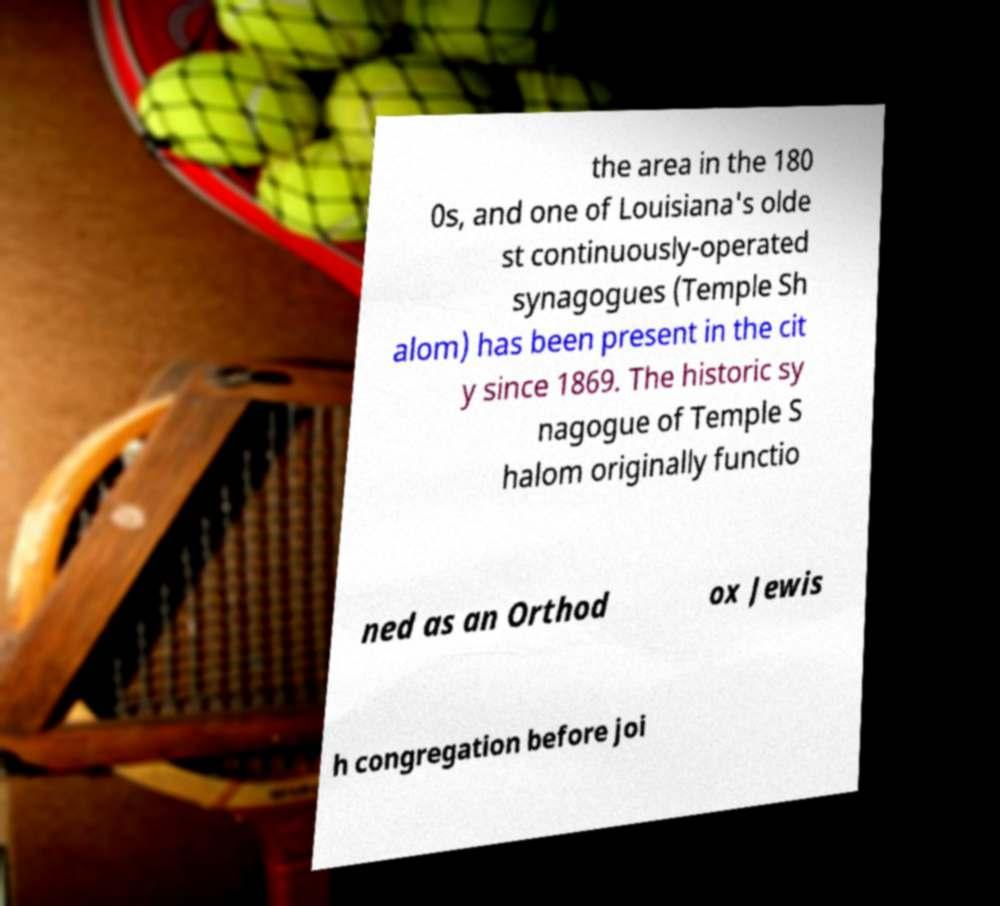Please read and relay the text visible in this image. What does it say? the area in the 180 0s, and one of Louisiana's olde st continuously-operated synagogues (Temple Sh alom) has been present in the cit y since 1869. The historic sy nagogue of Temple S halom originally functio ned as an Orthod ox Jewis h congregation before joi 